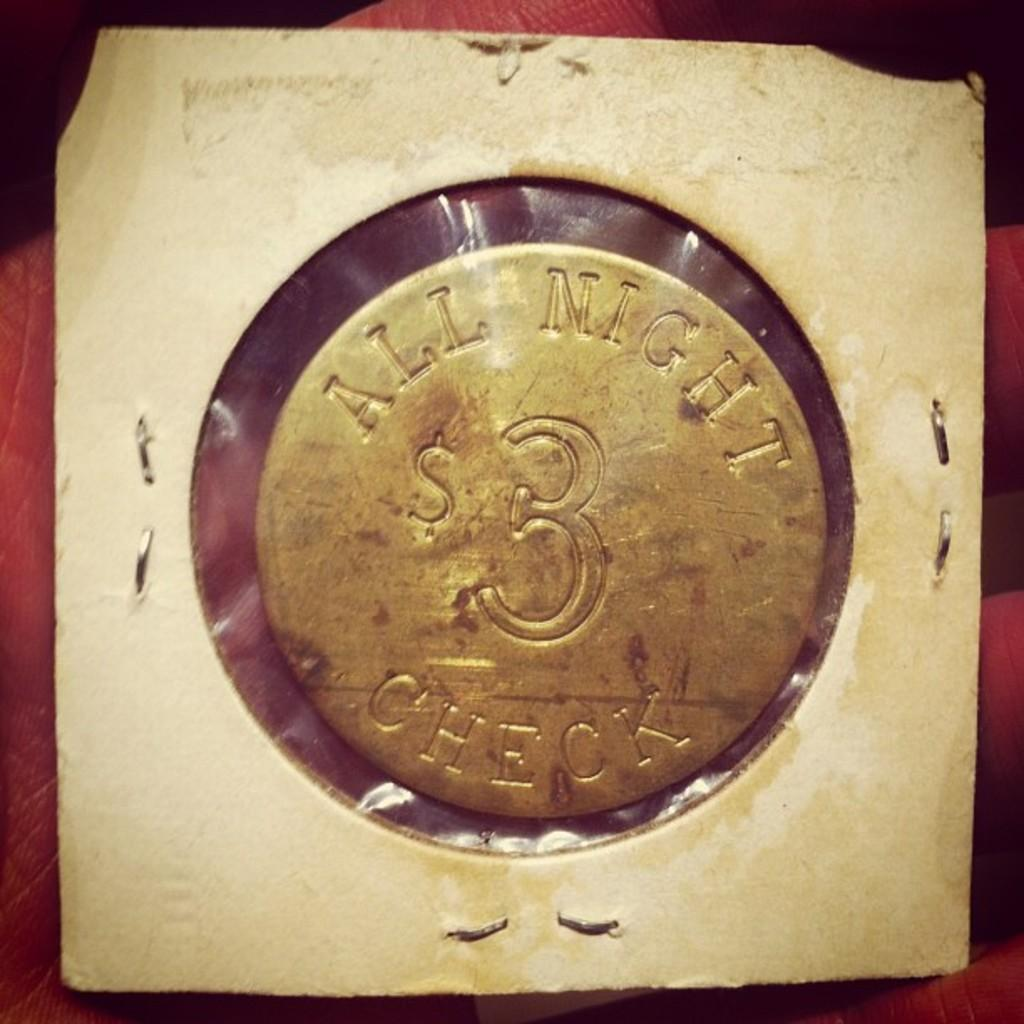<image>
Give a short and clear explanation of the subsequent image. a coin for All Night Check $3 in a coin protector 